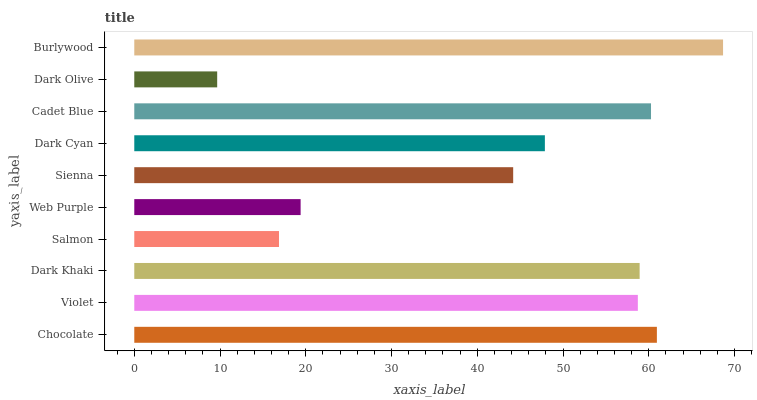Is Dark Olive the minimum?
Answer yes or no. Yes. Is Burlywood the maximum?
Answer yes or no. Yes. Is Violet the minimum?
Answer yes or no. No. Is Violet the maximum?
Answer yes or no. No. Is Chocolate greater than Violet?
Answer yes or no. Yes. Is Violet less than Chocolate?
Answer yes or no. Yes. Is Violet greater than Chocolate?
Answer yes or no. No. Is Chocolate less than Violet?
Answer yes or no. No. Is Violet the high median?
Answer yes or no. Yes. Is Dark Cyan the low median?
Answer yes or no. Yes. Is Salmon the high median?
Answer yes or no. No. Is Dark Khaki the low median?
Answer yes or no. No. 